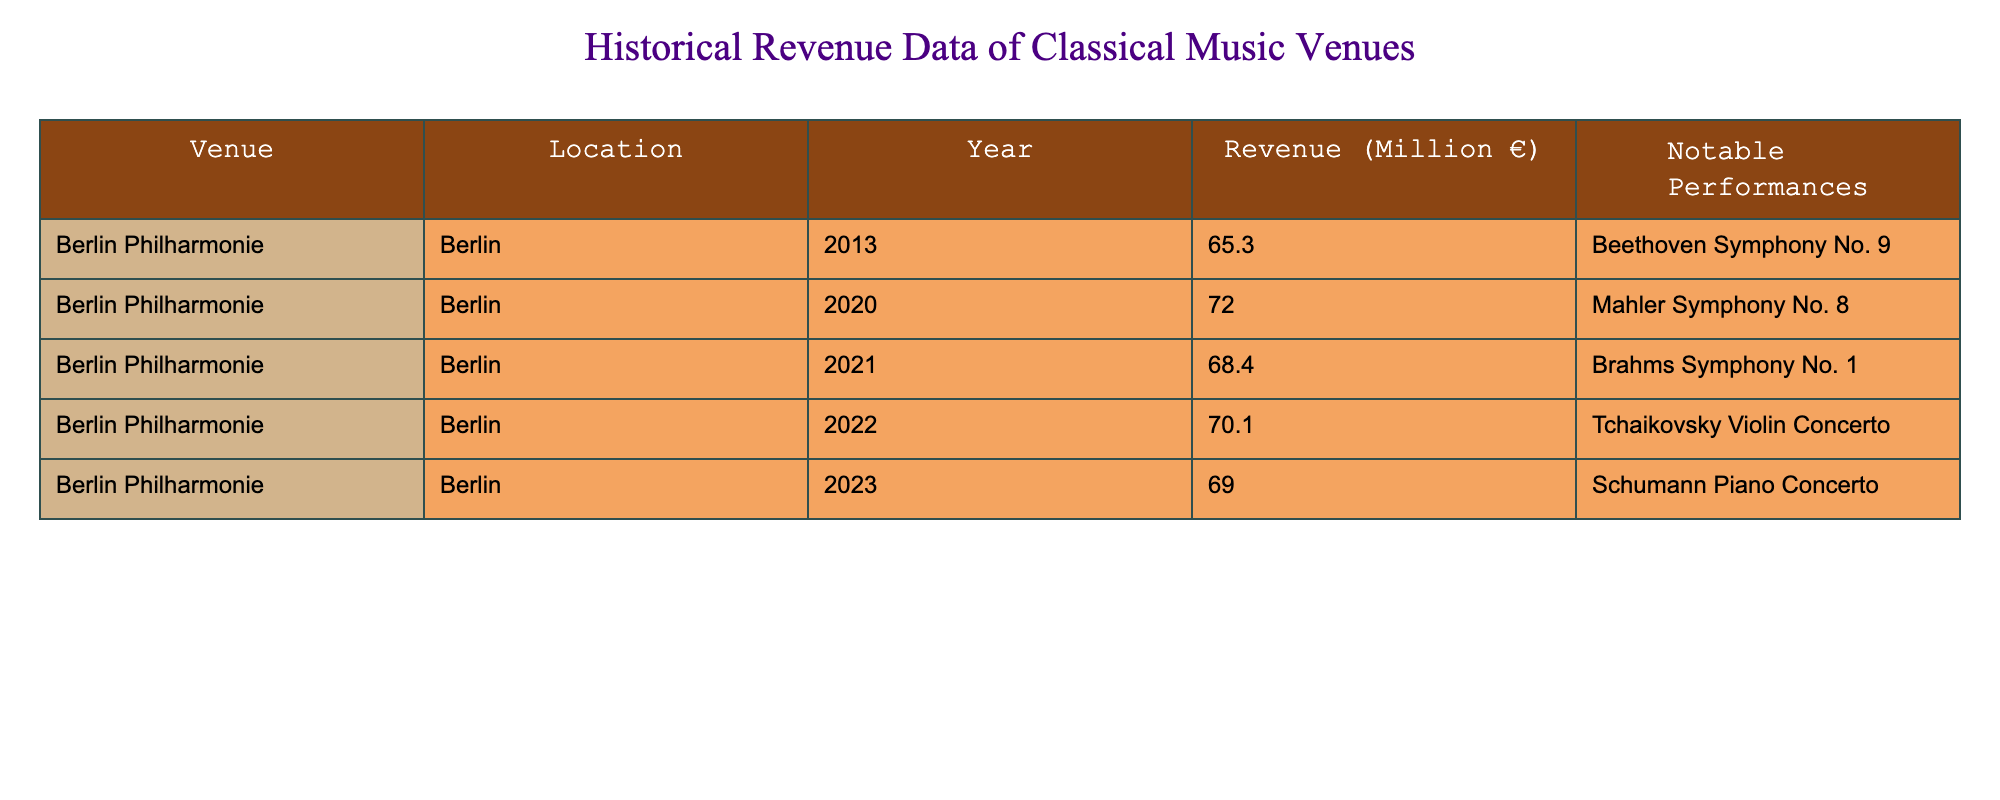What was the revenue of the Berlin Philharmonie in 2013? The table lists the revenue for each year. For 2013, looking at the row corresponding to that year, the revenue is recorded as 65.3 million euros.
Answer: 65.3 million € Which year saw the highest revenue for the Berlin Philharmonie? By reviewing all the revenue figures, I see that the maximum revenue occurred in 2020, recorded as 72.0 million euros.
Answer: 2020 What was the average revenue for the Berlin Philharmonie from 2013 to 2023? To calculate the average, sum the revenues of the years listed: (65.3 + 72.0 + 68.4 + 70.1 + 69.0) = 344.8 million euros. There are 5 years, so the average revenue is 344.8 / 5 = 68.96 million euros.
Answer: 68.96 million € Did the revenue increase from 2013 to 2020? By comparing the revenue figures, 2013 had a revenue of 65.3 million euros and 2020 had 72.0 million euros. Since 72.0 million is greater than 65.3 million, the revenue did increase.
Answer: Yes Which notable performance coincided with the lowest revenue during this period? The lowest revenue was in 2013 at 65.3 million euros, which coincided with the notable performance of Beethoven's Symphony No. 9.
Answer: Beethoven Symphony No. 9 What is the revenue difference between 2021 and 2022? The revenue for 2021 is 68.4 million euros and for 2022 is 70.1 million euros. To find the difference: 70.1 - 68.4 = 1.7 million euros, indicating an increase.
Answer: 1.7 million € Did the Berlin Philharmonie have a notable performance of Brahms Symphony No. 1 in a year of lower revenue compared to 2020? Brahms Symphony No. 1 was performed in 2021 when the revenue was 68.4 million euros, which is lower than 2020's revenue of 72.0 million euros.
Answer: Yes What were the revenues for the years where Mahler Symphony No. 8 was performed? Mahler Symphony No. 8 was performed in 2020, and the revenue for that year is 72.0 million euros. As there are no other mentioned performances here for Mahler, I refer solely to that year.
Answer: 72.0 million € How did the revenue in 2022 compare to the overall average revenue of the years from 2013 to 2022? The average revenue from 2013 to 2022 was calculated earlier as 68.96 million euros. The revenue in 2022 was 70.1 million euros, which is higher than this average (70.1 > 68.96).
Answer: Higher than average 